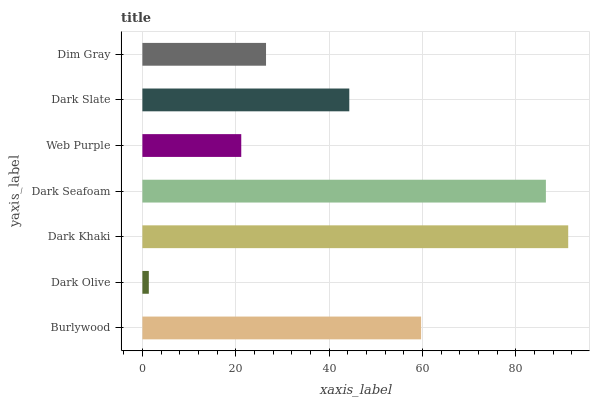Is Dark Olive the minimum?
Answer yes or no. Yes. Is Dark Khaki the maximum?
Answer yes or no. Yes. Is Dark Khaki the minimum?
Answer yes or no. No. Is Dark Olive the maximum?
Answer yes or no. No. Is Dark Khaki greater than Dark Olive?
Answer yes or no. Yes. Is Dark Olive less than Dark Khaki?
Answer yes or no. Yes. Is Dark Olive greater than Dark Khaki?
Answer yes or no. No. Is Dark Khaki less than Dark Olive?
Answer yes or no. No. Is Dark Slate the high median?
Answer yes or no. Yes. Is Dark Slate the low median?
Answer yes or no. Yes. Is Burlywood the high median?
Answer yes or no. No. Is Dark Khaki the low median?
Answer yes or no. No. 